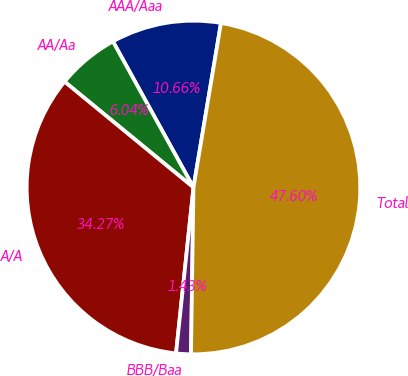<chart> <loc_0><loc_0><loc_500><loc_500><pie_chart><fcel>AAA/Aaa<fcel>AA/Aa<fcel>A/A<fcel>BBB/Baa<fcel>Total<nl><fcel>10.66%<fcel>6.04%<fcel>34.27%<fcel>1.43%<fcel>47.6%<nl></chart> 